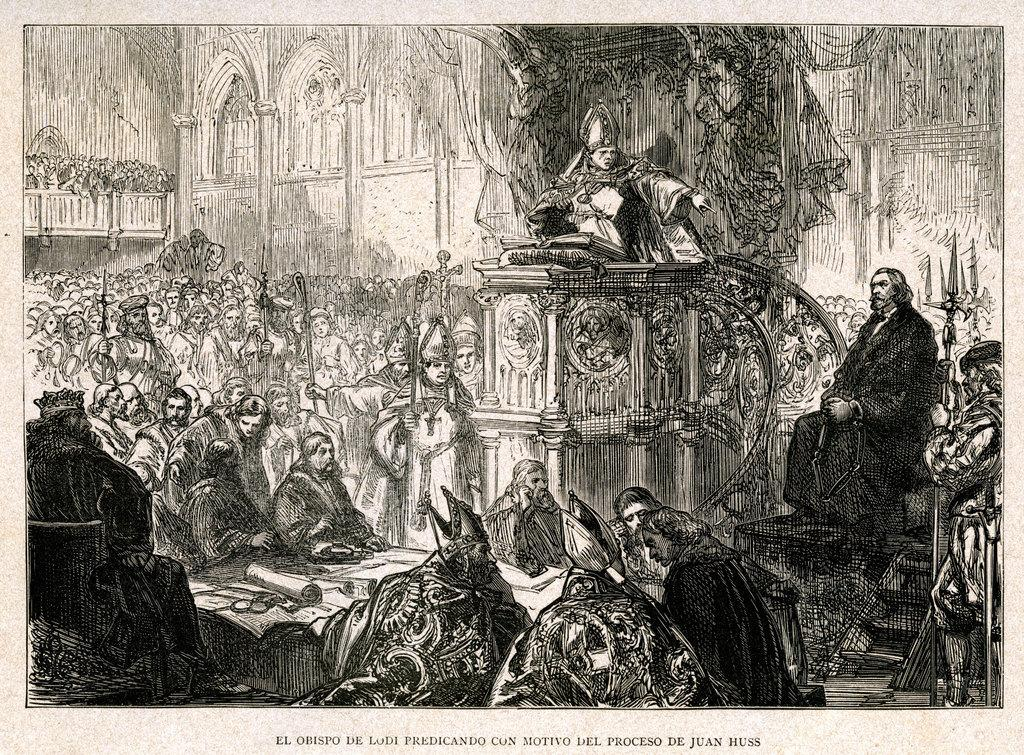What is the main subject of the image? The image contains a sketch of people. What type of background is depicted in the sketch? There is a wall depicted in the sketch. How would you describe the color scheme of the image? The image is black and white in color. Are there any words or letters in the image? Yes, there is text or writing present in the image. Where is the garden located in the image? There is no garden present in the image; it contains a sketch of people and a wall. How many birds are in the flock depicted in the image? There is no flock of birds depicted in the image; it contains a sketch of people and a wall. 